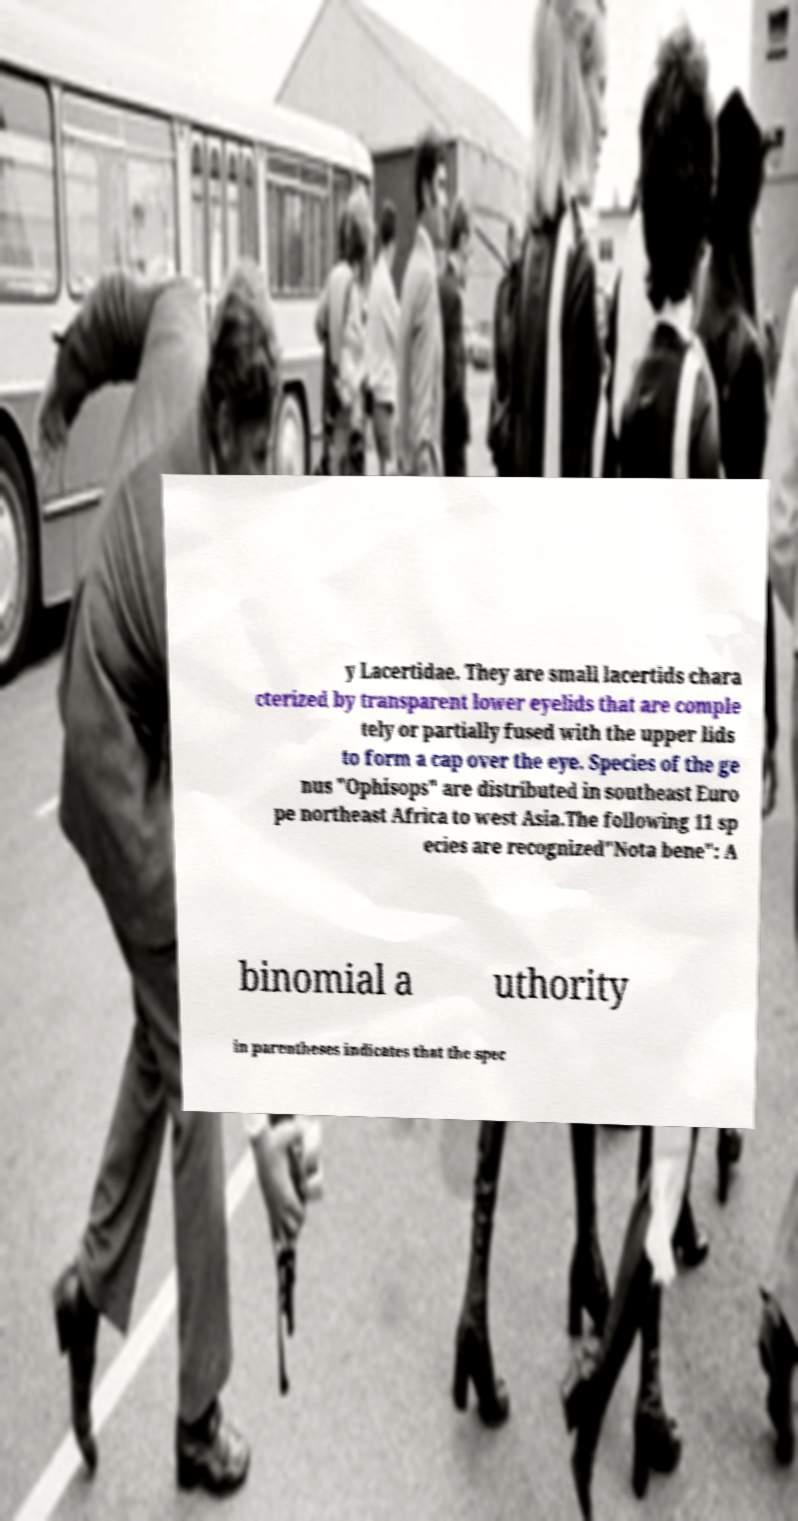Please identify and transcribe the text found in this image. y Lacertidae. They are small lacertids chara cterized by transparent lower eyelids that are comple tely or partially fused with the upper lids to form a cap over the eye. Species of the ge nus "Ophisops" are distributed in southeast Euro pe northeast Africa to west Asia.The following 11 sp ecies are recognized"Nota bene": A binomial a uthority in parentheses indicates that the spec 